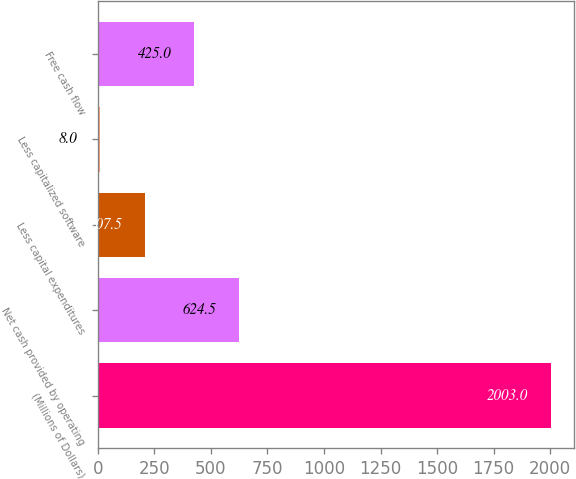Convert chart to OTSL. <chart><loc_0><loc_0><loc_500><loc_500><bar_chart><fcel>(Millions of Dollars)<fcel>Net cash provided by operating<fcel>Less capital expenditures<fcel>Less capitalized software<fcel>Free cash flow<nl><fcel>2003<fcel>624.5<fcel>207.5<fcel>8<fcel>425<nl></chart> 